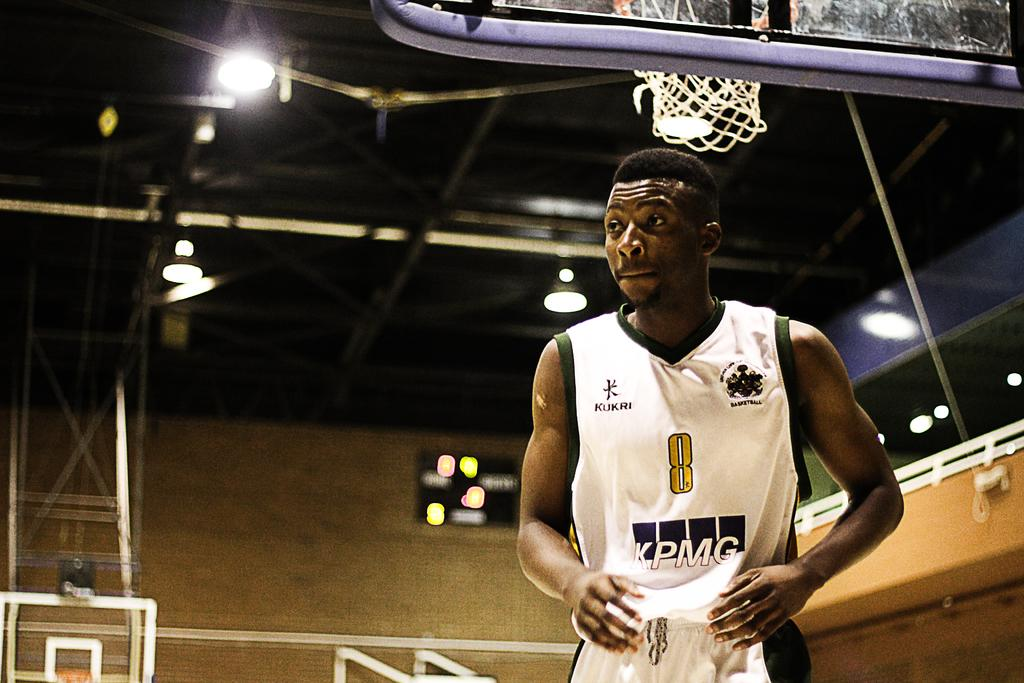Who is in the foreground of the picture? There is a man in the foreground of the picture. What is the man wearing? The man is wearing a white sports dress. Where is the man located? The man is in a basketball court. What can be seen in the background of the picture? There is a basket, a pole, a ceiling, a wall, lights, and pipes visible in the background. What type of joke is the man telling in the picture? There is no indication in the image that the man is telling a joke, as the focus is on his sports attire and location in a basketball court. 